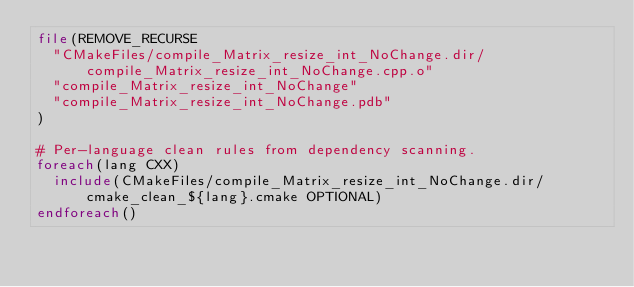<code> <loc_0><loc_0><loc_500><loc_500><_CMake_>file(REMOVE_RECURSE
  "CMakeFiles/compile_Matrix_resize_int_NoChange.dir/compile_Matrix_resize_int_NoChange.cpp.o"
  "compile_Matrix_resize_int_NoChange"
  "compile_Matrix_resize_int_NoChange.pdb"
)

# Per-language clean rules from dependency scanning.
foreach(lang CXX)
  include(CMakeFiles/compile_Matrix_resize_int_NoChange.dir/cmake_clean_${lang}.cmake OPTIONAL)
endforeach()
</code> 